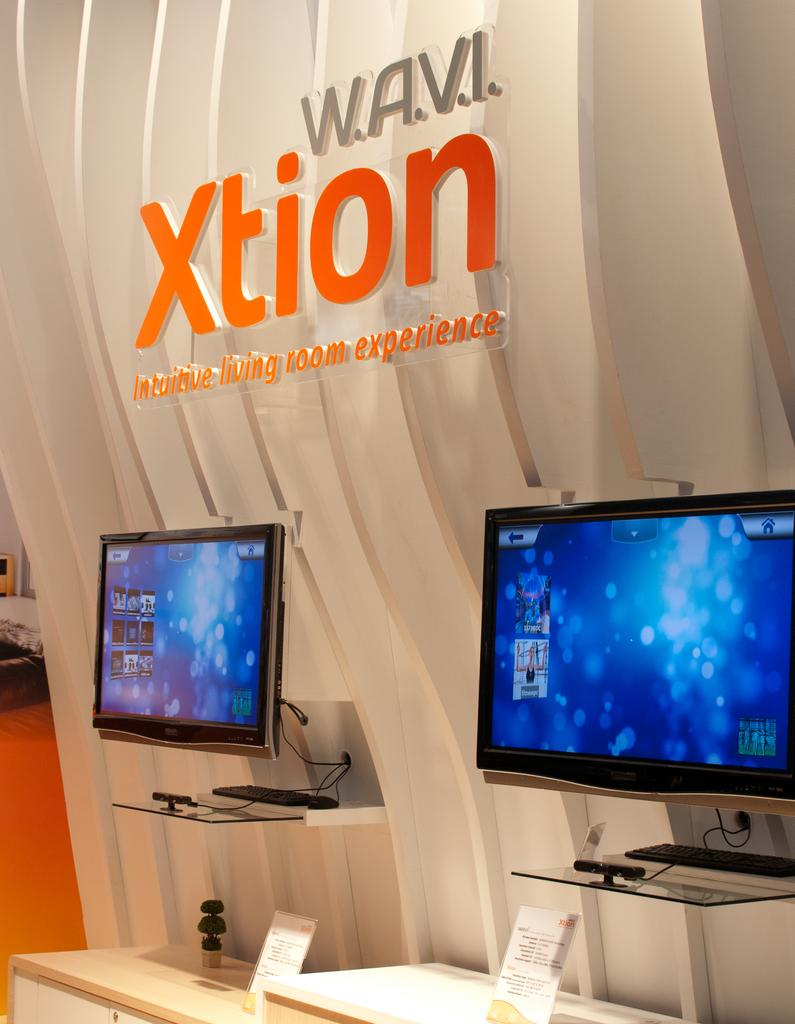<image>
Give a short and clear explanation of the subsequent image. Computer displayed with "WAVI Xtion" displaying in the background. 